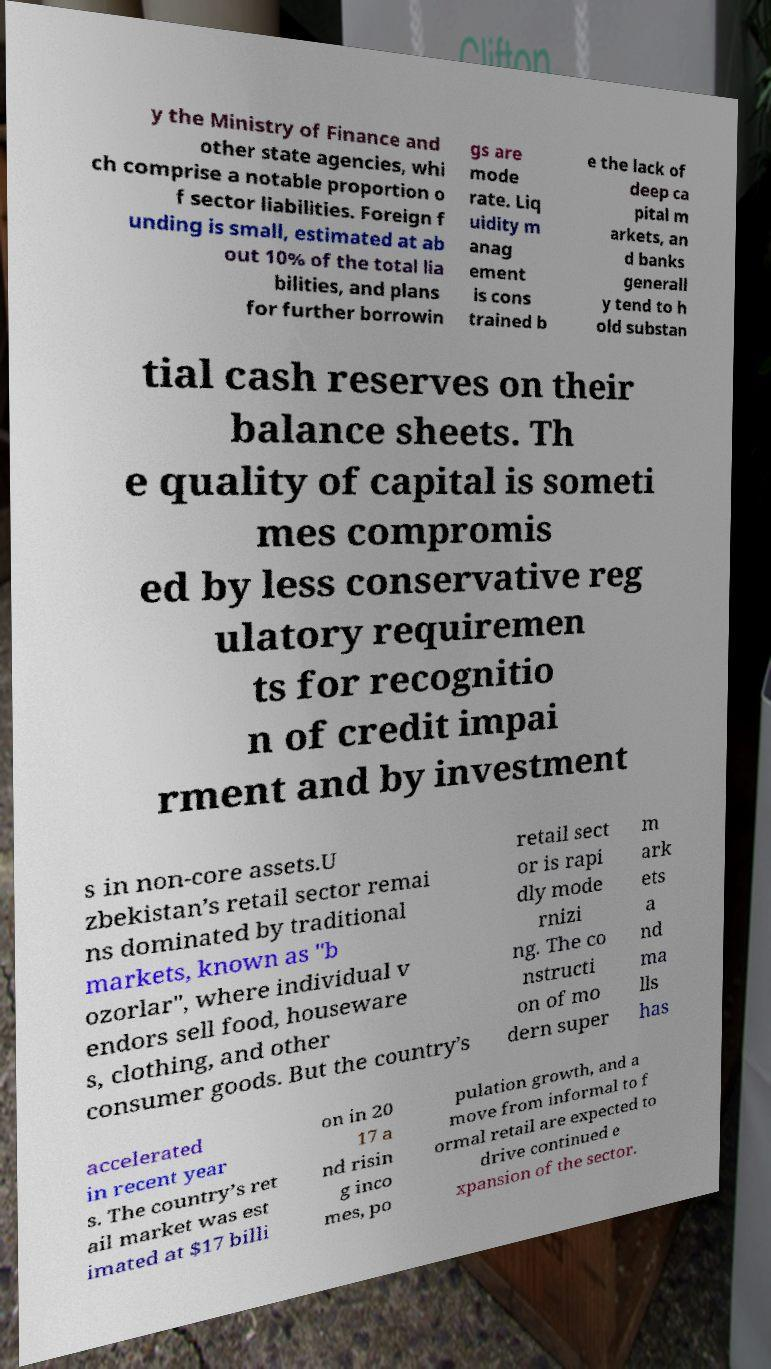What messages or text are displayed in this image? I need them in a readable, typed format. y the Ministry of Finance and other state agencies, whi ch comprise a notable proportion o f sector liabilities. Foreign f unding is small, estimated at ab out 10% of the total lia bilities, and plans for further borrowin gs are mode rate. Liq uidity m anag ement is cons trained b e the lack of deep ca pital m arkets, an d banks generall y tend to h old substan tial cash reserves on their balance sheets. Th e quality of capital is someti mes compromis ed by less conservative reg ulatory requiremen ts for recognitio n of credit impai rment and by investment s in non-core assets.U zbekistan’s retail sector remai ns dominated by traditional markets, known as "b ozorlar", where individual v endors sell food, houseware s, clothing, and other consumer goods. But the country’s retail sect or is rapi dly mode rnizi ng. The co nstructi on of mo dern super m ark ets a nd ma lls has accelerated in recent year s. The country’s ret ail market was est imated at $17 billi on in 20 17 a nd risin g inco mes, po pulation growth, and a move from informal to f ormal retail are expected to drive continued e xpansion of the sector. 